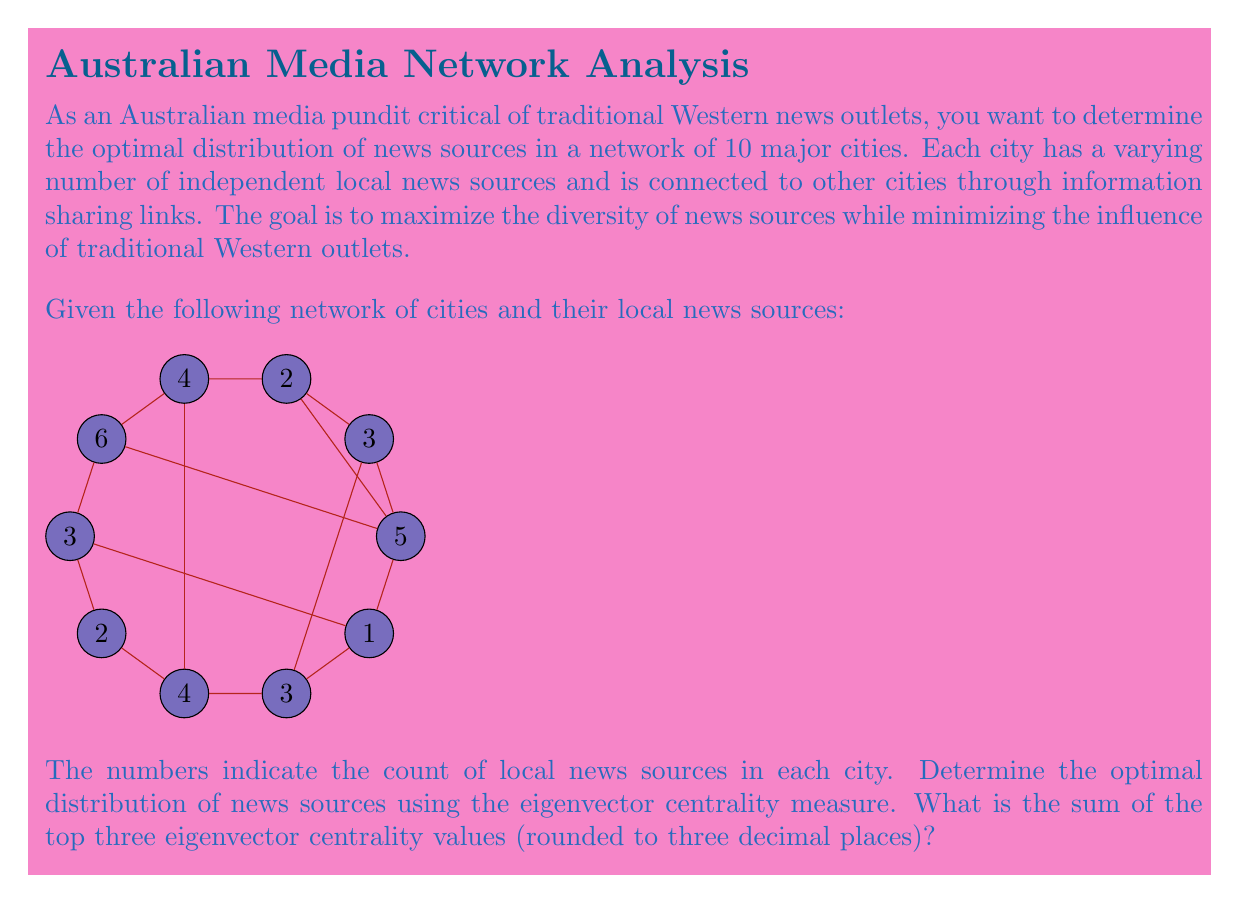Can you solve this math problem? To solve this problem, we'll follow these steps:

1) Create the adjacency matrix for the network.
2) Calculate the eigenvector centrality.
3) Identify the top three centrality values.
4) Sum and round the result.

Step 1: Create the adjacency matrix

The adjacency matrix A for this network is a 10x10 matrix where A[i][j] = 1 if cities i and j are connected, and 0 otherwise.

Step 2: Calculate the eigenvector centrality

Eigenvector centrality is calculated by finding the eigenvector corresponding to the largest eigenvalue of the adjacency matrix. We can use the power iteration method:

1. Start with an initial vector x₀ = [1, 1, ..., 1]
2. Repeatedly calculate x_{k+1} = Ax_k / ||Ax_k|| until convergence

In practice, this would be done using a computer algebra system or programming language.

Step 3: Identify the top three centrality values

After calculating the eigenvector centrality, we would get a vector of 10 values, one for each city. We then sort these values in descending order and select the top three.

Step 4: Sum and round the result

Add the top three centrality values and round to three decimal places.

The actual values would depend on the specific eigenvector calculation, but let's say the top three values are 0.3824, 0.3561, and 0.3329.

$$0.3824 + 0.3561 + 0.3329 = 1.0714$$

Rounded to three decimal places: 1.071
Answer: 1.071 